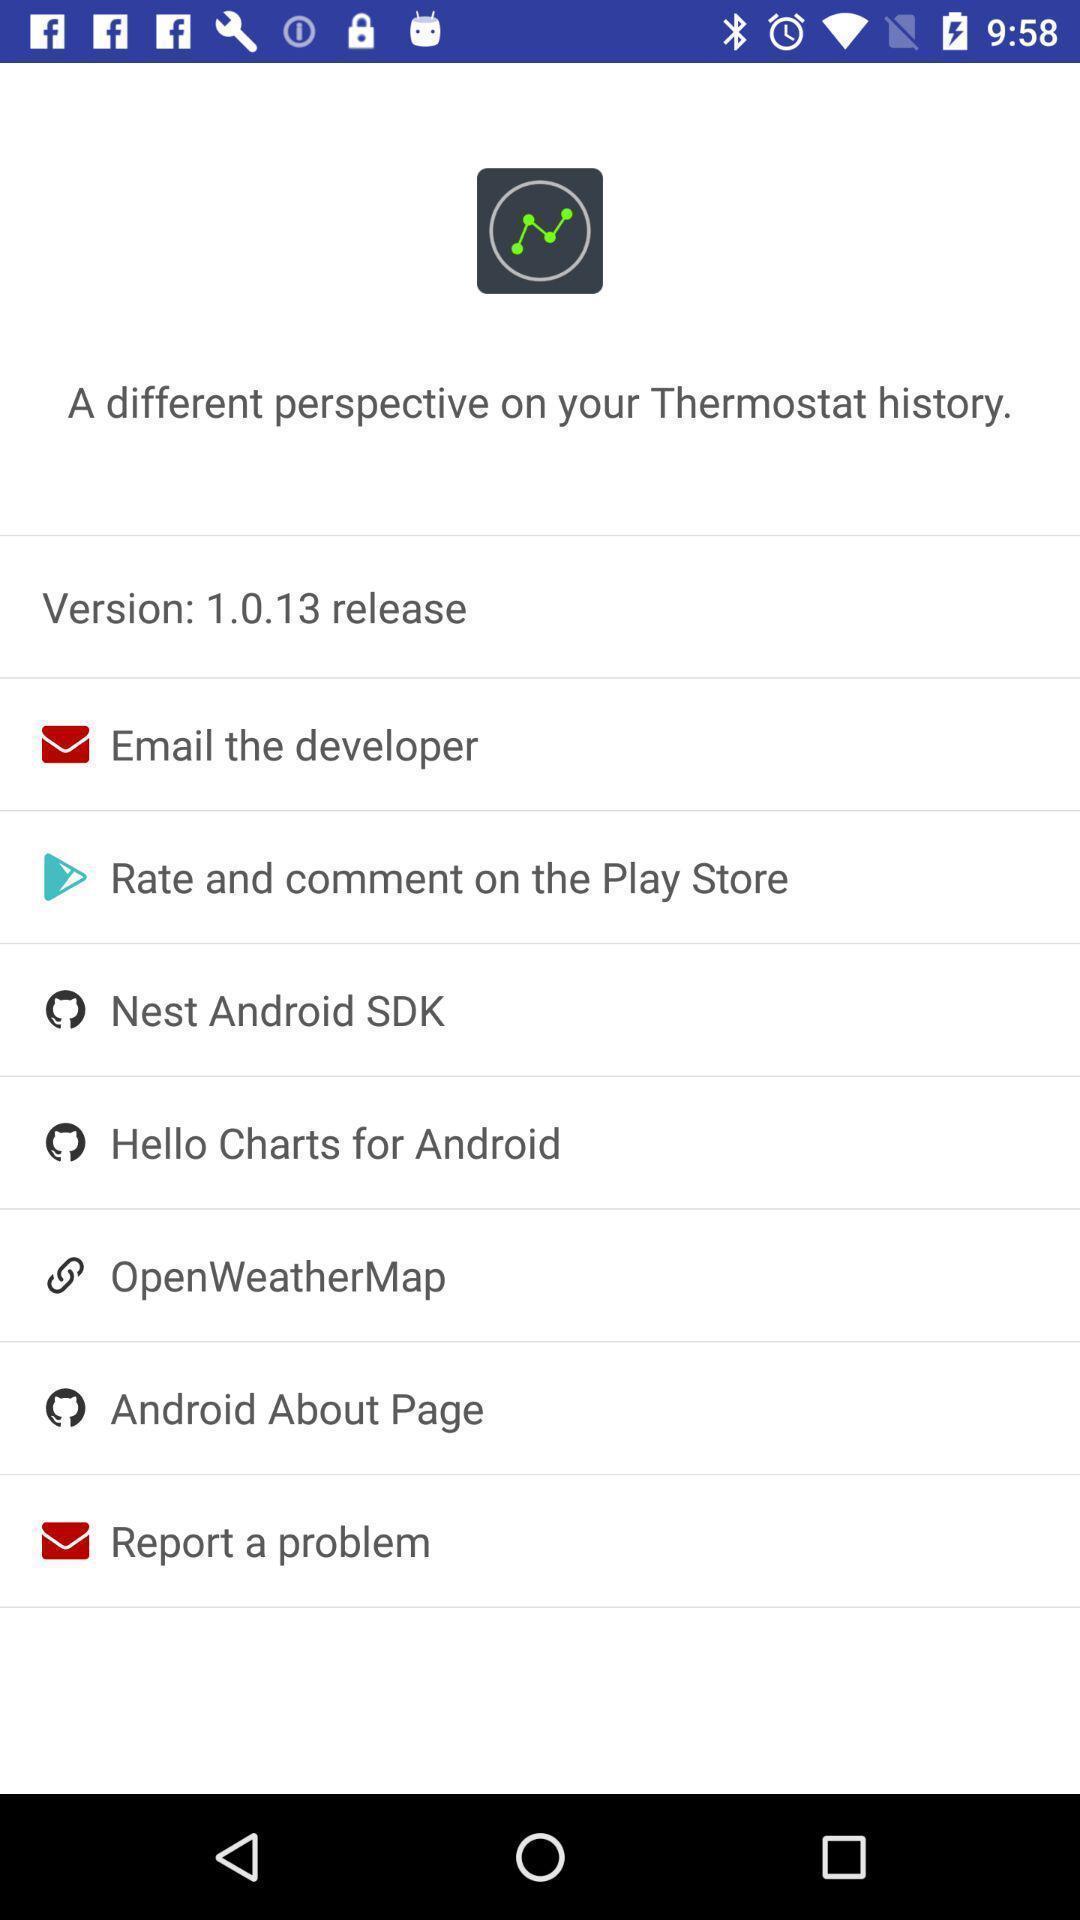What can you discern from this picture? Updated version of the app. 